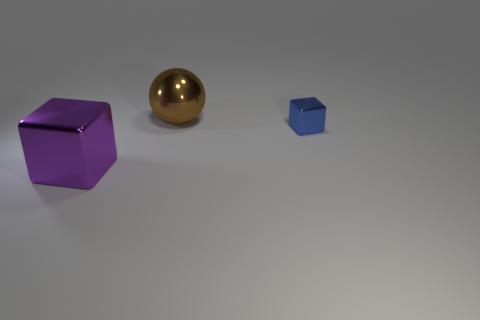How many large purple objects are behind the block behind the big metallic thing in front of the large brown sphere?
Provide a succinct answer. 0. What color is the thing behind the block to the right of the purple block?
Offer a terse response. Brown. How many other things are there of the same material as the purple thing?
Your answer should be very brief. 2. How many balls are on the left side of the big thing that is right of the large purple thing?
Keep it short and to the point. 0. Are there any other things that have the same shape as the brown thing?
Give a very brief answer. No. Is the number of large purple cubes less than the number of large metal things?
Ensure brevity in your answer.  Yes. There is a large thing behind the shiny cube on the left side of the small metal object; what shape is it?
Offer a very short reply. Sphere. Are there any other things that have the same size as the blue shiny block?
Your response must be concise. No. What is the shape of the big object behind the tiny block that is on the right side of the big object that is in front of the small blue block?
Offer a very short reply. Sphere. What number of things are either metal cubes right of the brown sphere or blocks right of the brown ball?
Your response must be concise. 1. 